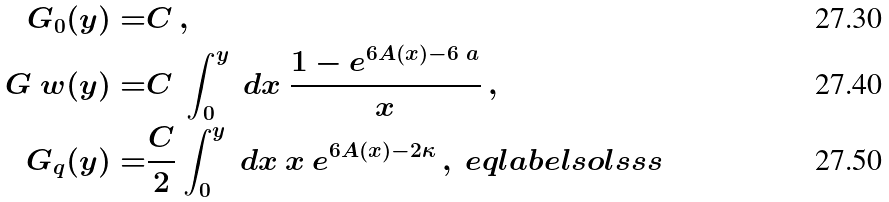Convert formula to latex. <formula><loc_0><loc_0><loc_500><loc_500>G _ { 0 } ( y ) = & C \, , \\ G _ { \ } w ( y ) = & C \ \int _ { 0 } ^ { y } \ d x \ \frac { 1 - e ^ { 6 A ( x ) - 6 \ a } } { x } \, , \\ G _ { q } ( y ) = & \frac { C } { 2 } \int _ { 0 } ^ { y } \ d x \ x \ e ^ { 6 A ( x ) - 2 \kappa } \, , \ e q l a b e l { s o l s s s }</formula> 